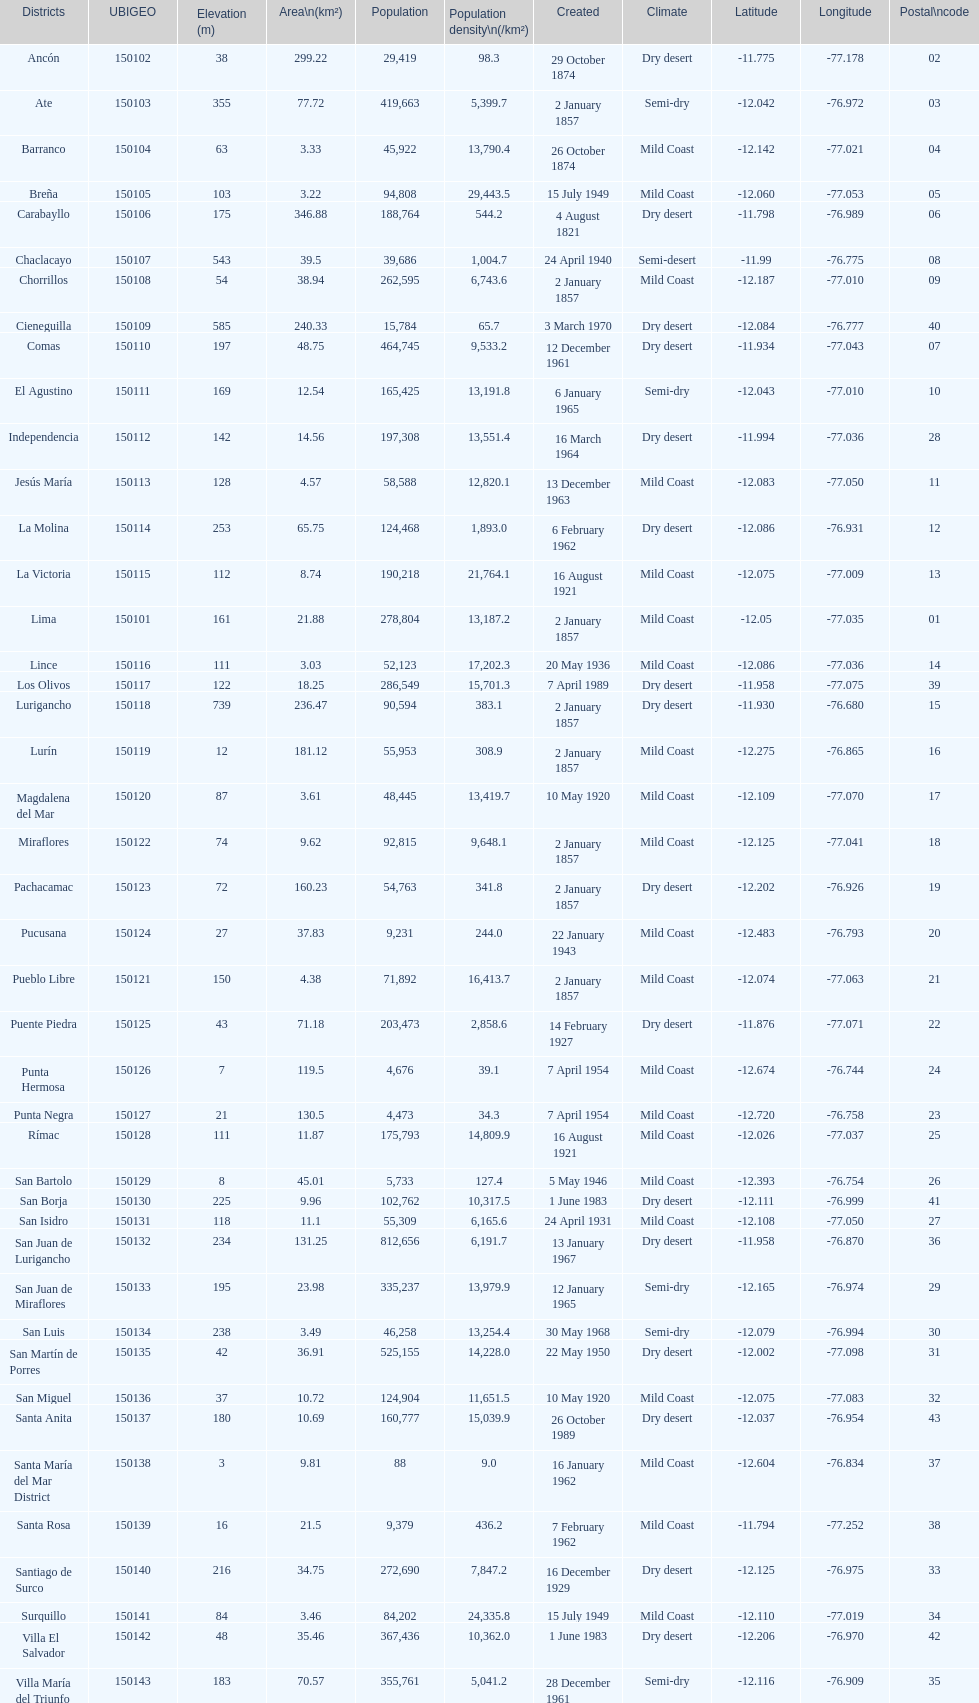How many districts have a population density of at lest 1000.0? 31. Would you be able to parse every entry in this table? {'header': ['Districts', 'UBIGEO', 'Elevation (m)', 'Area\\n(km²)', 'Population', 'Population density\\n(/km²)', 'Created', 'Climate', 'Latitude', 'Longitude', 'Postal\\ncode'], 'rows': [['Ancón', '150102', '38', '299.22', '29,419', '98.3', '29 October 1874', 'Dry desert', '-11.775', '-77.178', '02'], ['Ate', '150103', '355', '77.72', '419,663', '5,399.7', '2 January 1857', 'Semi-dry', '-12.042', '-76.972', '03'], ['Barranco', '150104', '63', '3.33', '45,922', '13,790.4', '26 October 1874', 'Mild Coast', '-12.142', '-77.021', '04'], ['Breña', '150105', '103', '3.22', '94,808', '29,443.5', '15 July 1949', 'Mild Coast', '-12.060', '-77.053', '05'], ['Carabayllo', '150106', '175', '346.88', '188,764', '544.2', '4 August 1821', 'Dry desert', '-11.798', '-76.989', '06'], ['Chaclacayo', '150107', '543', '39.5', '39,686', '1,004.7', '24 April 1940', 'Semi-desert', '-11.99', '-76.775', '08'], ['Chorrillos', '150108', '54', '38.94', '262,595', '6,743.6', '2 January 1857', 'Mild Coast', '-12.187', '-77.010', '09'], ['Cieneguilla', '150109', '585', '240.33', '15,784', '65.7', '3 March 1970', 'Dry desert', '-12.084', '-76.777', '40'], ['Comas', '150110', '197', '48.75', '464,745', '9,533.2', '12 December 1961', 'Dry desert', '-11.934', '-77.043', '07'], ['El Agustino', '150111', '169', '12.54', '165,425', '13,191.8', '6 January 1965', 'Semi-dry', '-12.043', '-77.010', '10'], ['Independencia', '150112', '142', '14.56', '197,308', '13,551.4', '16 March 1964', 'Dry desert', '-11.994', '-77.036', '28'], ['Jesús María', '150113', '128', '4.57', '58,588', '12,820.1', '13 December 1963', 'Mild Coast', '-12.083', '-77.050', '11'], ['La Molina', '150114', '253', '65.75', '124,468', '1,893.0', '6 February 1962', 'Dry desert', '-12.086', '-76.931', '12'], ['La Victoria', '150115', '112', '8.74', '190,218', '21,764.1', '16 August 1921', 'Mild Coast', '-12.075', '-77.009', '13'], ['Lima', '150101', '161', '21.88', '278,804', '13,187.2', '2 January 1857', 'Mild Coast', '-12.05', '-77.035', '01'], ['Lince', '150116', '111', '3.03', '52,123', '17,202.3', '20 May 1936', 'Mild Coast', '-12.086', '-77.036', '14'], ['Los Olivos', '150117', '122', '18.25', '286,549', '15,701.3', '7 April 1989', 'Dry desert', '-11.958', '-77.075', '39'], ['Lurigancho', '150118', '739', '236.47', '90,594', '383.1', '2 January 1857', 'Dry desert', '-11.930', '-76.680', '15'], ['Lurín', '150119', '12', '181.12', '55,953', '308.9', '2 January 1857', 'Mild Coast', '-12.275', '-76.865', '16'], ['Magdalena del Mar', '150120', '87', '3.61', '48,445', '13,419.7', '10 May 1920', 'Mild Coast', '-12.109', '-77.070', '17'], ['Miraflores', '150122', '74', '9.62', '92,815', '9,648.1', '2 January 1857', 'Mild Coast', '-12.125', '-77.041', '18'], ['Pachacamac', '150123', '72', '160.23', '54,763', '341.8', '2 January 1857', 'Dry desert', '-12.202', '-76.926', '19'], ['Pucusana', '150124', '27', '37.83', '9,231', '244.0', '22 January 1943', 'Mild Coast', '-12.483', '-76.793', '20'], ['Pueblo Libre', '150121', '150', '4.38', '71,892', '16,413.7', '2 January 1857', 'Mild Coast', '-12.074', '-77.063', '21'], ['Puente Piedra', '150125', '43', '71.18', '203,473', '2,858.6', '14 February 1927', 'Dry desert', '-11.876', '-77.071', '22'], ['Punta Hermosa', '150126', '7', '119.5', '4,676', '39.1', '7 April 1954', 'Mild Coast', '-12.674', '-76.744', '24'], ['Punta Negra', '150127', '21', '130.5', '4,473', '34.3', '7 April 1954', 'Mild Coast', '-12.720', '-76.758', '23'], ['Rímac', '150128', '111', '11.87', '175,793', '14,809.9', '16 August 1921', 'Mild Coast', '-12.026', '-77.037', '25'], ['San Bartolo', '150129', '8', '45.01', '5,733', '127.4', '5 May 1946', 'Mild Coast', '-12.393', '-76.754', '26'], ['San Borja', '150130', '225', '9.96', '102,762', '10,317.5', '1 June 1983', 'Dry desert', '-12.111', '-76.999', '41'], ['San Isidro', '150131', '118', '11.1', '55,309', '6,165.6', '24 April 1931', 'Mild Coast', '-12.108', '-77.050', '27'], ['San Juan de Lurigancho', '150132', '234', '131.25', '812,656', '6,191.7', '13 January 1967', 'Dry desert', '-11.958', '-76.870', '36'], ['San Juan de Miraflores', '150133', '195', '23.98', '335,237', '13,979.9', '12 January 1965', 'Semi-dry', '-12.165', '-76.974', '29'], ['San Luis', '150134', '238', '3.49', '46,258', '13,254.4', '30 May 1968', 'Semi-dry', '-12.079', '-76.994', '30'], ['San Martín de Porres', '150135', '42', '36.91', '525,155', '14,228.0', '22 May 1950', 'Dry desert', '-12.002', '-77.098', '31'], ['San Miguel', '150136', '37', '10.72', '124,904', '11,651.5', '10 May 1920', 'Mild Coast', '-12.075', '-77.083', '32'], ['Santa Anita', '150137', '180', '10.69', '160,777', '15,039.9', '26 October 1989', 'Dry desert', '-12.037', '-76.954', '43'], ['Santa María del Mar District', '150138', '3', '9.81', '88', '9.0', '16 January 1962', 'Mild Coast', '-12.604', '-76.834', '37'], ['Santa Rosa', '150139', '16', '21.5', '9,379', '436.2', '7 February 1962', 'Mild Coast', '-11.794', '-77.252', '38'], ['Santiago de Surco', '150140', '216', '34.75', '272,690', '7,847.2', '16 December 1929', 'Dry desert', '-12.125', '-76.975', '33'], ['Surquillo', '150141', '84', '3.46', '84,202', '24,335.8', '15 July 1949', 'Mild Coast', '-12.110', '-77.019', '34'], ['Villa El Salvador', '150142', '48', '35.46', '367,436', '10,362.0', '1 June 1983', 'Dry desert', '-12.206', '-76.970', '42'], ['Villa María del Triunfo', '150143', '183', '70.57', '355,761', '5,041.2', '28 December 1961', 'Semi-dry', '-12.116', '-76.909', '35']]} 